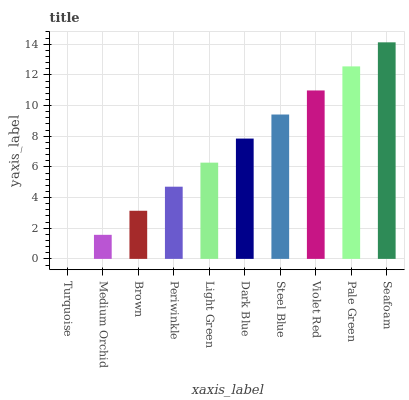Is Turquoise the minimum?
Answer yes or no. Yes. Is Seafoam the maximum?
Answer yes or no. Yes. Is Medium Orchid the minimum?
Answer yes or no. No. Is Medium Orchid the maximum?
Answer yes or no. No. Is Medium Orchid greater than Turquoise?
Answer yes or no. Yes. Is Turquoise less than Medium Orchid?
Answer yes or no. Yes. Is Turquoise greater than Medium Orchid?
Answer yes or no. No. Is Medium Orchid less than Turquoise?
Answer yes or no. No. Is Dark Blue the high median?
Answer yes or no. Yes. Is Light Green the low median?
Answer yes or no. Yes. Is Pale Green the high median?
Answer yes or no. No. Is Periwinkle the low median?
Answer yes or no. No. 